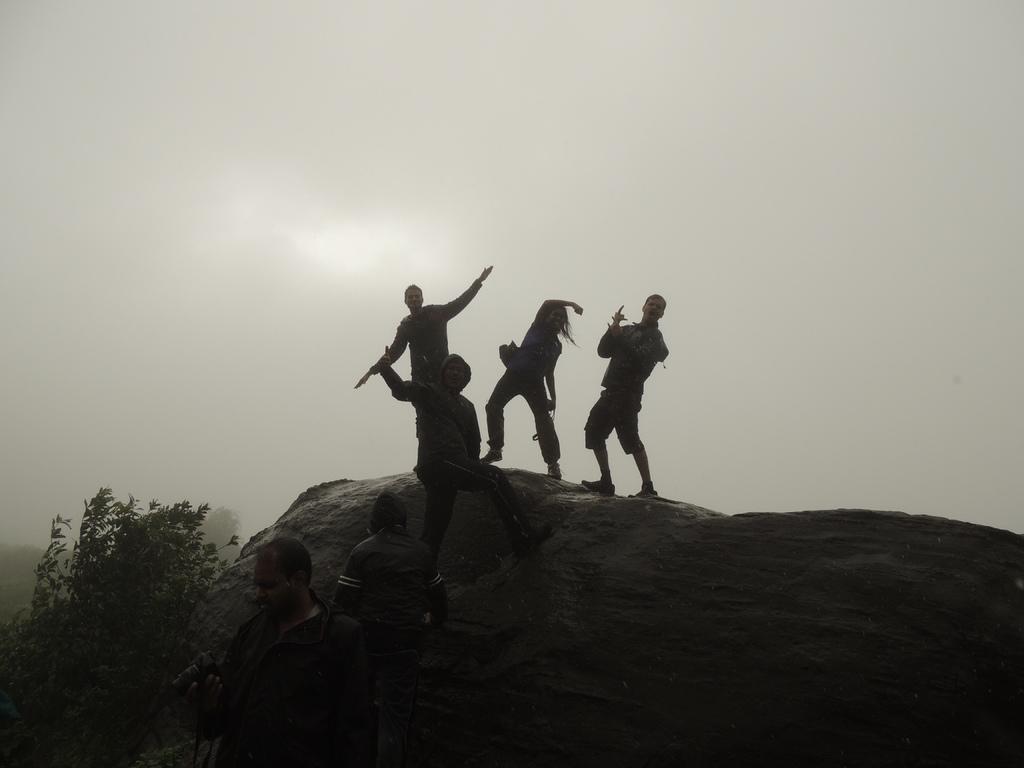Could you give a brief overview of what you see in this image? In the image there are few persons standing on the rock and above its sky. 